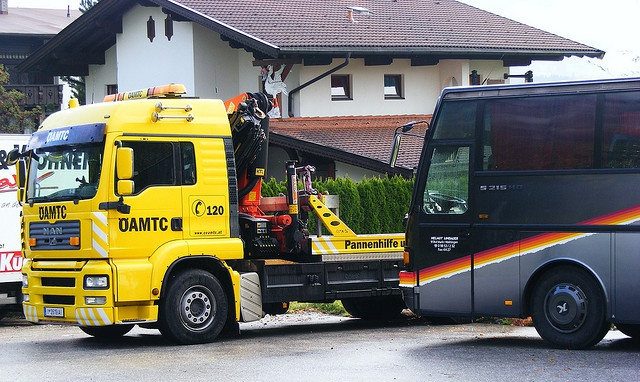Describe the objects in this image and their specific colors. I can see truck in gray, black, gold, and ivory tones and bus in gray, black, and blue tones in this image. 